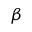Convert formula to latex. <formula><loc_0><loc_0><loc_500><loc_500>\beta</formula> 